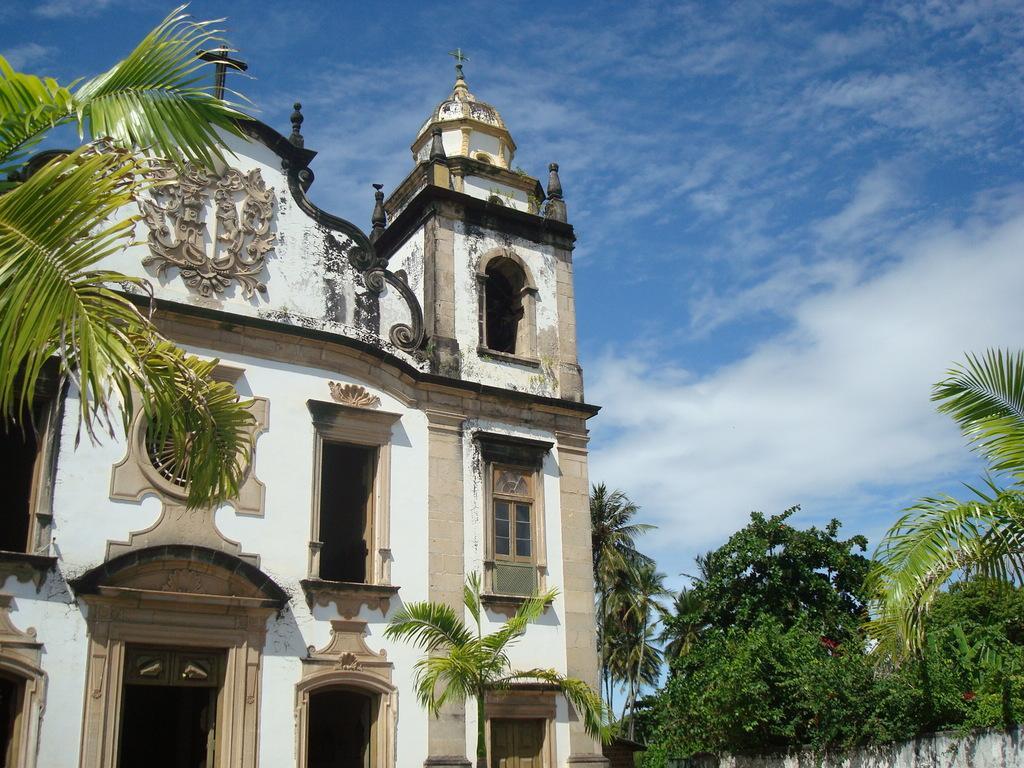Describe this image in one or two sentences. In this picture I can see a building and few trees and I can see a blue cloudy sky. 